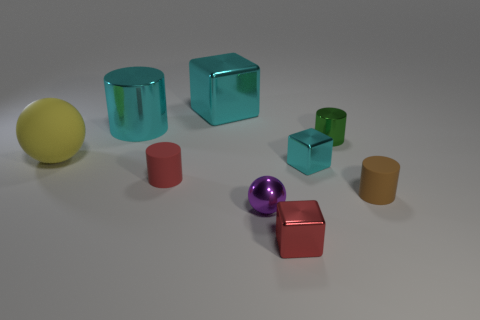Do the cyan cylinder and the red shiny cube have the same size? Upon visual inspection of the image, it appears that the cyan cylinder and the red shiny cube do not have the same size. The cyan cylinder is taller and has a smaller diameter, whereas the red shiny cube looks to be shorter in height but has more width on each side, creating different dimensions overall. 